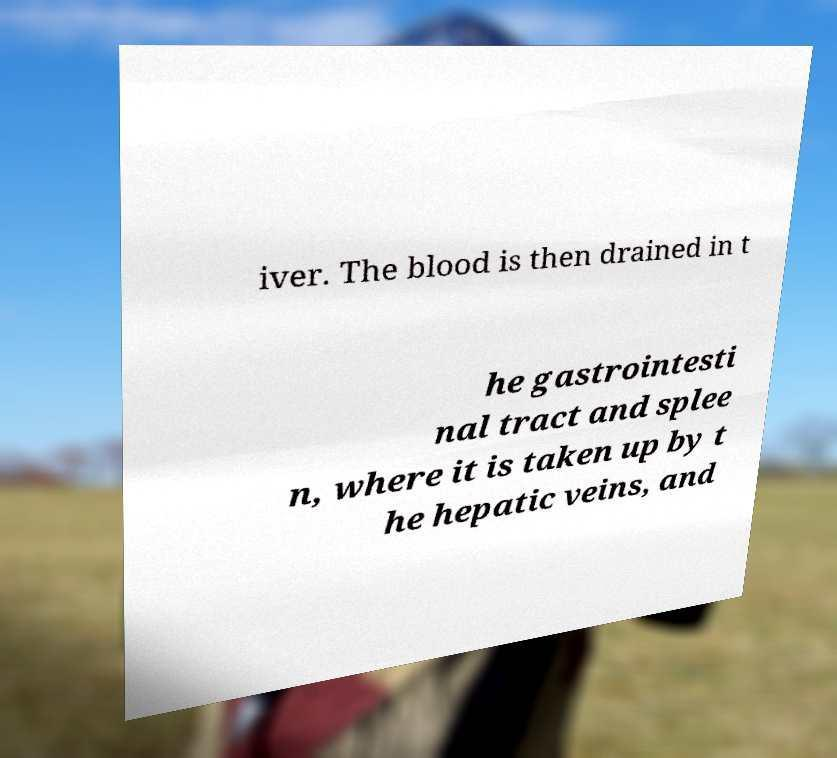Can you accurately transcribe the text from the provided image for me? iver. The blood is then drained in t he gastrointesti nal tract and splee n, where it is taken up by t he hepatic veins, and 